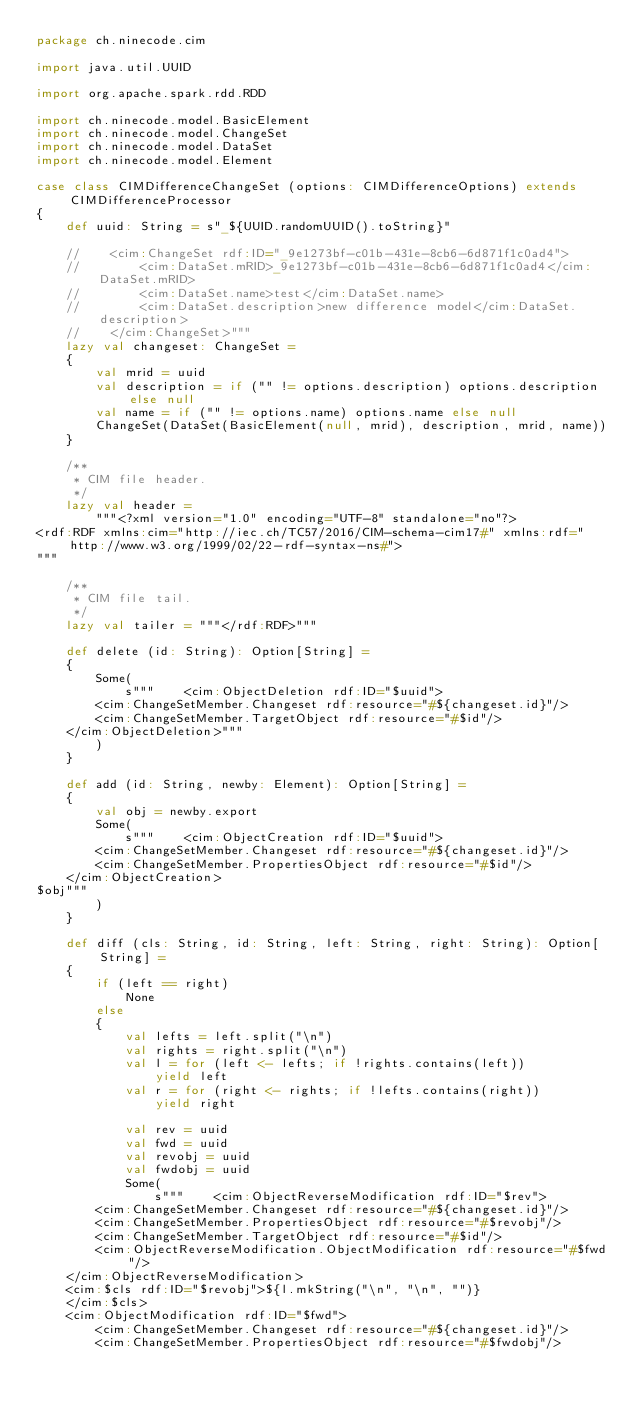<code> <loc_0><loc_0><loc_500><loc_500><_Scala_>package ch.ninecode.cim

import java.util.UUID

import org.apache.spark.rdd.RDD

import ch.ninecode.model.BasicElement
import ch.ninecode.model.ChangeSet
import ch.ninecode.model.DataSet
import ch.ninecode.model.Element

case class CIMDifferenceChangeSet (options: CIMDifferenceOptions) extends CIMDifferenceProcessor
{
    def uuid: String = s"_${UUID.randomUUID().toString}"

    //    <cim:ChangeSet rdf:ID="_9e1273bf-c01b-431e-8cb6-6d871f1c0ad4">
    //        <cim:DataSet.mRID>_9e1273bf-c01b-431e-8cb6-6d871f1c0ad4</cim:DataSet.mRID>
    //        <cim:DataSet.name>test</cim:DataSet.name>
    //        <cim:DataSet.description>new difference model</cim:DataSet.description>
    //    </cim:ChangeSet>"""
    lazy val changeset: ChangeSet =
    {
        val mrid = uuid
        val description = if ("" != options.description) options.description else null
        val name = if ("" != options.name) options.name else null
        ChangeSet(DataSet(BasicElement(null, mrid), description, mrid, name))
    }

    /**
     * CIM file header.
     */
    lazy val header =
        """<?xml version="1.0" encoding="UTF-8" standalone="no"?>
<rdf:RDF xmlns:cim="http://iec.ch/TC57/2016/CIM-schema-cim17#" xmlns:rdf="http://www.w3.org/1999/02/22-rdf-syntax-ns#">
"""

    /**
     * CIM file tail.
     */
    lazy val tailer = """</rdf:RDF>"""

    def delete (id: String): Option[String] =
    {
        Some(
            s"""	<cim:ObjectDeletion rdf:ID="$uuid">
		<cim:ChangeSetMember.Changeset rdf:resource="#${changeset.id}"/>
		<cim:ChangeSetMember.TargetObject rdf:resource="#$id"/>
	</cim:ObjectDeletion>"""
        )
    }

    def add (id: String, newby: Element): Option[String] =
    {
        val obj = newby.export
        Some(
            s"""	<cim:ObjectCreation rdf:ID="$uuid">
		<cim:ChangeSetMember.Changeset rdf:resource="#${changeset.id}"/>
		<cim:ChangeSetMember.PropertiesObject rdf:resource="#$id"/>
	</cim:ObjectCreation>
$obj"""
        )
    }

    def diff (cls: String, id: String, left: String, right: String): Option[String] =
    {
        if (left == right)
            None
        else
        {
            val lefts = left.split("\n")
            val rights = right.split("\n")
            val l = for (left <- lefts; if !rights.contains(left))
                yield left
            val r = for (right <- rights; if !lefts.contains(right))
                yield right

            val rev = uuid
            val fwd = uuid
            val revobj = uuid
            val fwdobj = uuid
            Some(
                s"""	<cim:ObjectReverseModification rdf:ID="$rev">
		<cim:ChangeSetMember.Changeset rdf:resource="#${changeset.id}"/>
		<cim:ChangeSetMember.PropertiesObject rdf:resource="#$revobj"/>
		<cim:ChangeSetMember.TargetObject rdf:resource="#$id"/>
		<cim:ObjectReverseModification.ObjectModification rdf:resource="#$fwd"/>
	</cim:ObjectReverseModification>
	<cim:$cls rdf:ID="$revobj">${l.mkString("\n", "\n", "")}
	</cim:$cls>
	<cim:ObjectModification rdf:ID="$fwd">
		<cim:ChangeSetMember.Changeset rdf:resource="#${changeset.id}"/>
		<cim:ChangeSetMember.PropertiesObject rdf:resource="#$fwdobj"/></code> 